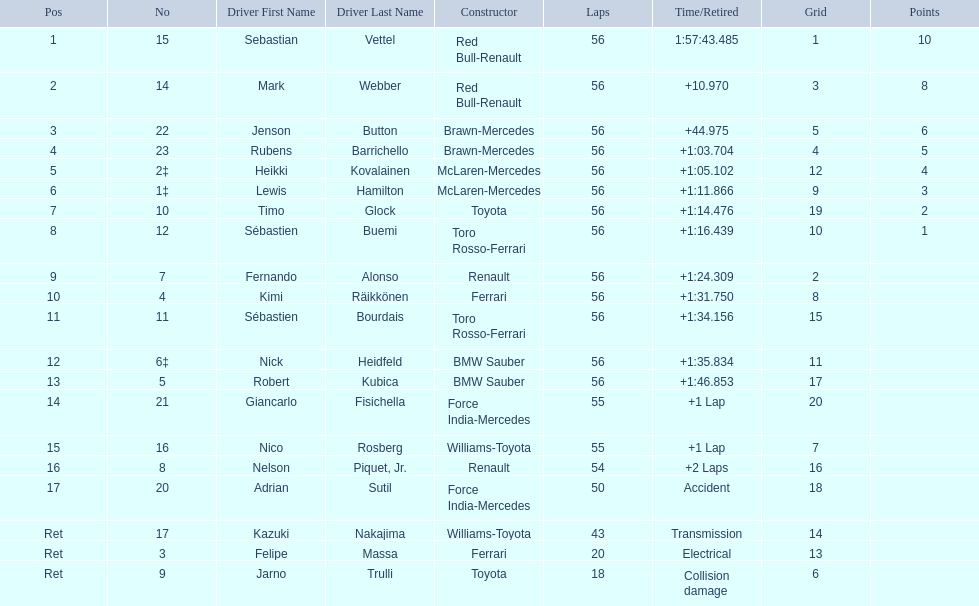Which drivers took part in the 2009 chinese grand prix? Sebastian Vettel, Mark Webber, Jenson Button, Rubens Barrichello, Heikki Kovalainen, Lewis Hamilton, Timo Glock, Sébastien Buemi, Fernando Alonso, Kimi Räikkönen, Sébastien Bourdais, Nick Heidfeld, Robert Kubica, Giancarlo Fisichella, Nico Rosberg, Nelson Piquet, Jr., Adrian Sutil, Kazuki Nakajima, Felipe Massa, Jarno Trulli. Of these, who completed all 56 laps? Sebastian Vettel, Mark Webber, Jenson Button, Rubens Barrichello, Heikki Kovalainen, Lewis Hamilton, Timo Glock, Sébastien Buemi, Fernando Alonso, Kimi Räikkönen, Sébastien Bourdais, Nick Heidfeld, Robert Kubica. Of these, which did ferrari not participate as a constructor? Sebastian Vettel, Mark Webber, Jenson Button, Rubens Barrichello, Heikki Kovalainen, Lewis Hamilton, Timo Glock, Fernando Alonso, Kimi Räikkönen, Nick Heidfeld, Robert Kubica. Of the remaining, which is in pos 1? Sebastian Vettel. 